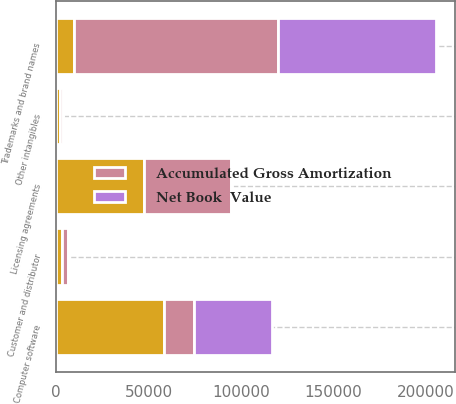Convert chart. <chart><loc_0><loc_0><loc_500><loc_500><stacked_bar_chart><ecel><fcel>Trademarks and brand names<fcel>Licensing agreements<fcel>Customer and distributor<fcel>Computer software<fcel>Other intangibles<nl><fcel>nan<fcel>9732<fcel>47600<fcel>3200<fcel>58494<fcel>1900<nl><fcel>Net Book  Value<fcel>85175<fcel>585<fcel>96<fcel>42230<fcel>24<nl><fcel>Accumulated Gross Amortization<fcel>110363<fcel>47015<fcel>3104<fcel>16264<fcel>1876<nl></chart> 